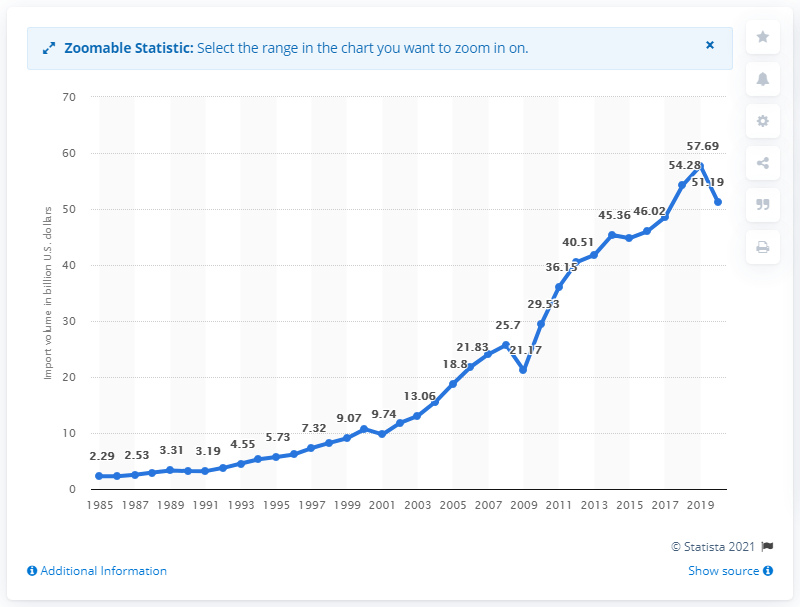Give some essential details in this illustration. In 2020, the value of U.S. imports from India was 51.19 billion dollars. 